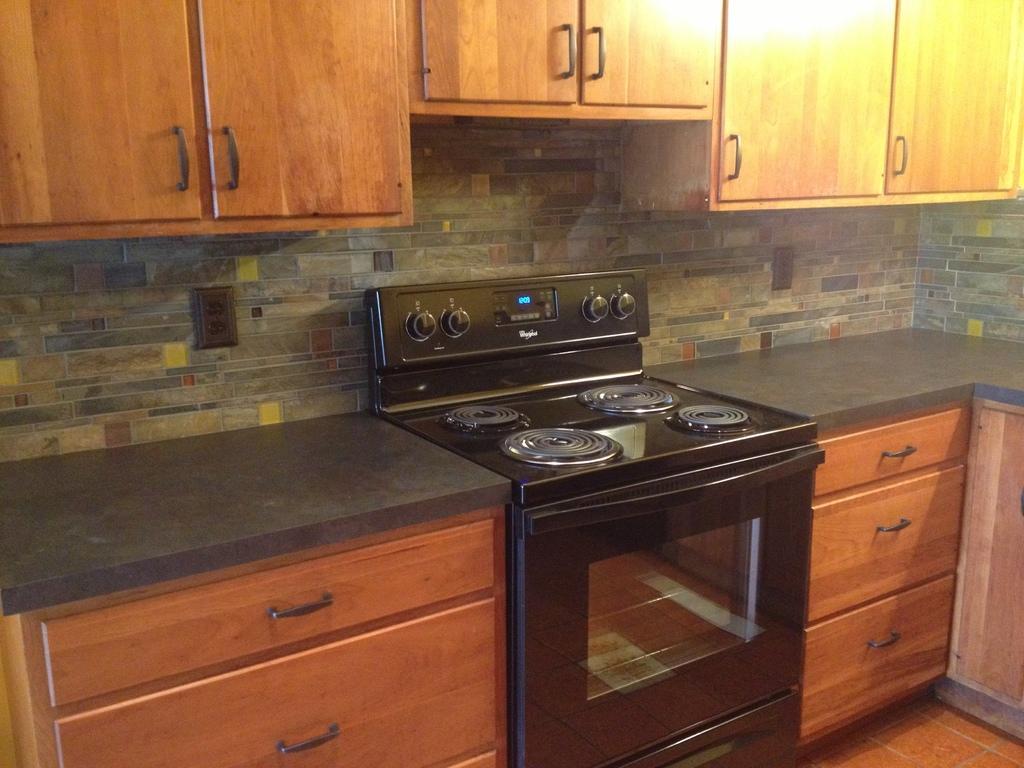Could you give a brief overview of what you see in this image? There is a black color stove and a micro oven and there are few cupboards on either sides and above above it. 